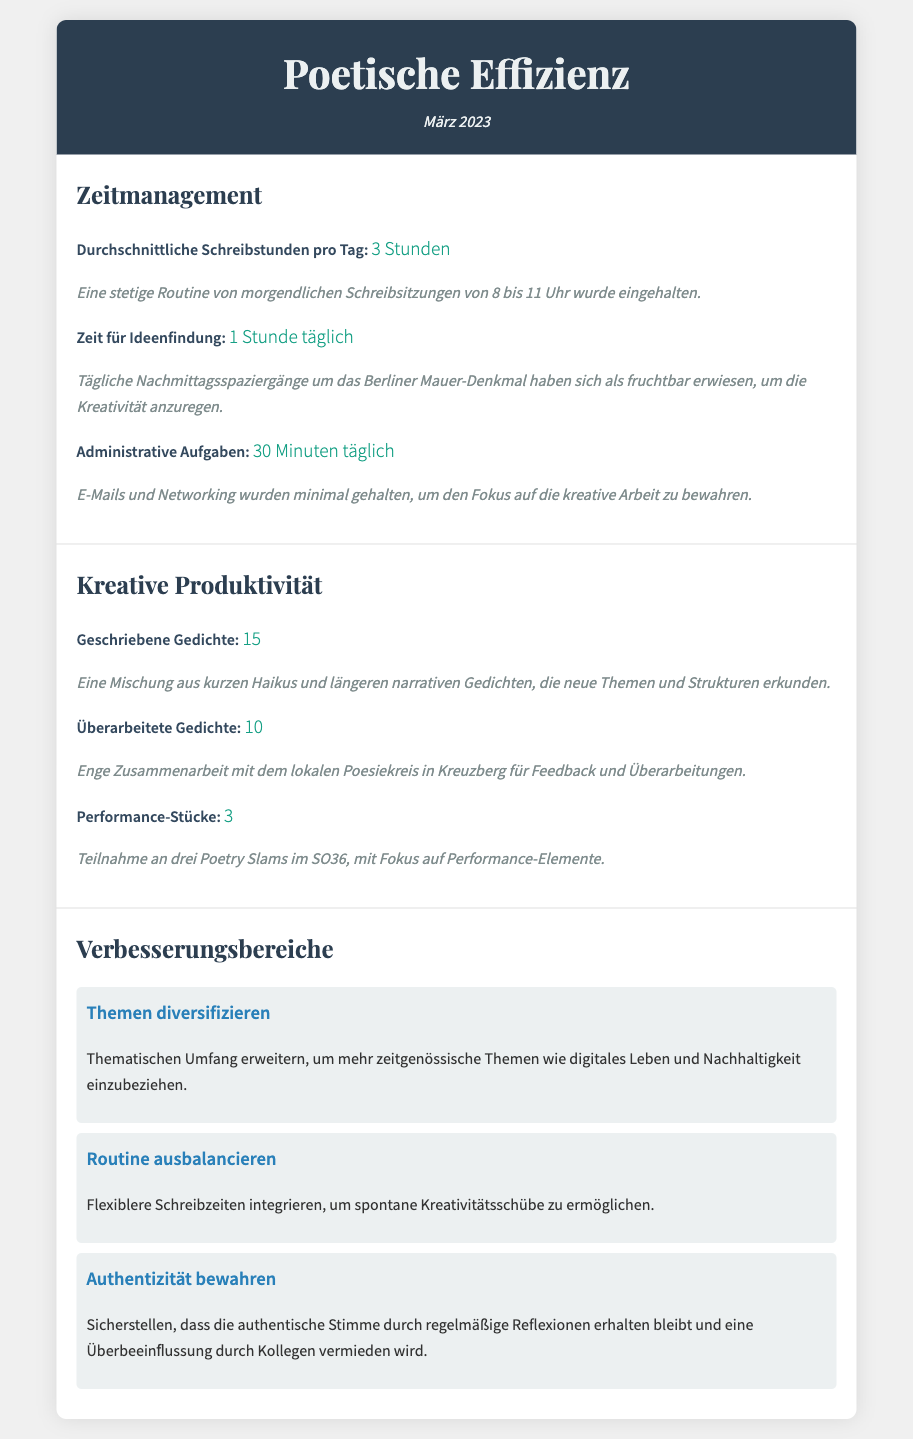Was ist die durchschnittliche Schreibstunden pro Tag? Die durchschnittlichen Schreibstunden pro Tag sind in der Sektion Zeitmanagement aufgeführt.
Answer: 3 Stunden Wie viele Gedichte wurden im März 2023 geschrieben? Die Anzahl der im März 2023 geschriebenen Gedichte steht in der Sektion Kreative Produktivität.
Answer: 15 Wie viel Zeit wird täglich für Ideenfindung aufgewendet? Die tägliche Zeit für Ideenfindung kann in der Zeitmanagement-Sektion nachgelesen werden.
Answer: 1 Stunde täglich Wie viele Performance-Stücke wurden vorgetragen? Die Anzahl der vorgetragenen Performance-Stücke wird in der Sektion Kreative Produktivität genannt.
Answer: 3 Was ist ein vorgeschlagener Verbesserungsbereich? In der Sektion Verbesserungsbereiche werden verschiedene Themen aufgeführt, die verbessert werden sollten.
Answer: Themen diversifizieren Wann fanden die täglichen Schreibsitzungen statt? Die Zeiten der täglichen Schreibsitzungen sind in der Zeitmanagement-Sektion beschrieben.
Answer: von 8 bis 11 Uhr Wie viele überarbeitete Gedichte hat der Autor pro Woche? Die Anzahl der überarbeiteten Gedichte wird in der Sektion Kreative Produktivität erwähnt.
Answer: 10 Was wurde unternommen, um die authentische Stimme zu bewahren? Die Maßnahmen zur Bewahrung der authentischen Stimme werden in der Sektion Verbesserungsbereiche genannt.
Answer: Regelmäßige Reflexionen 